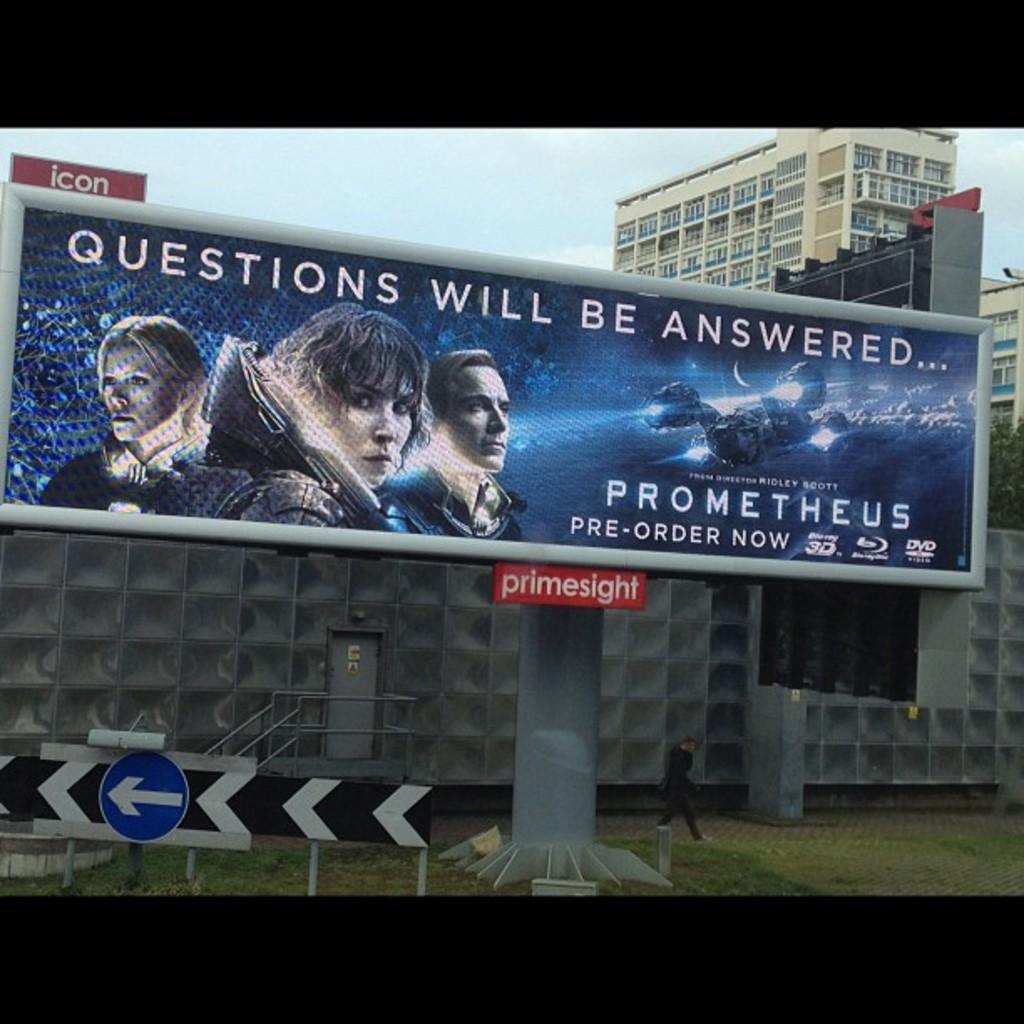<image>
Offer a succinct explanation of the picture presented. A billboard is advertising the movie Prometheus with portrayals of the characters. 